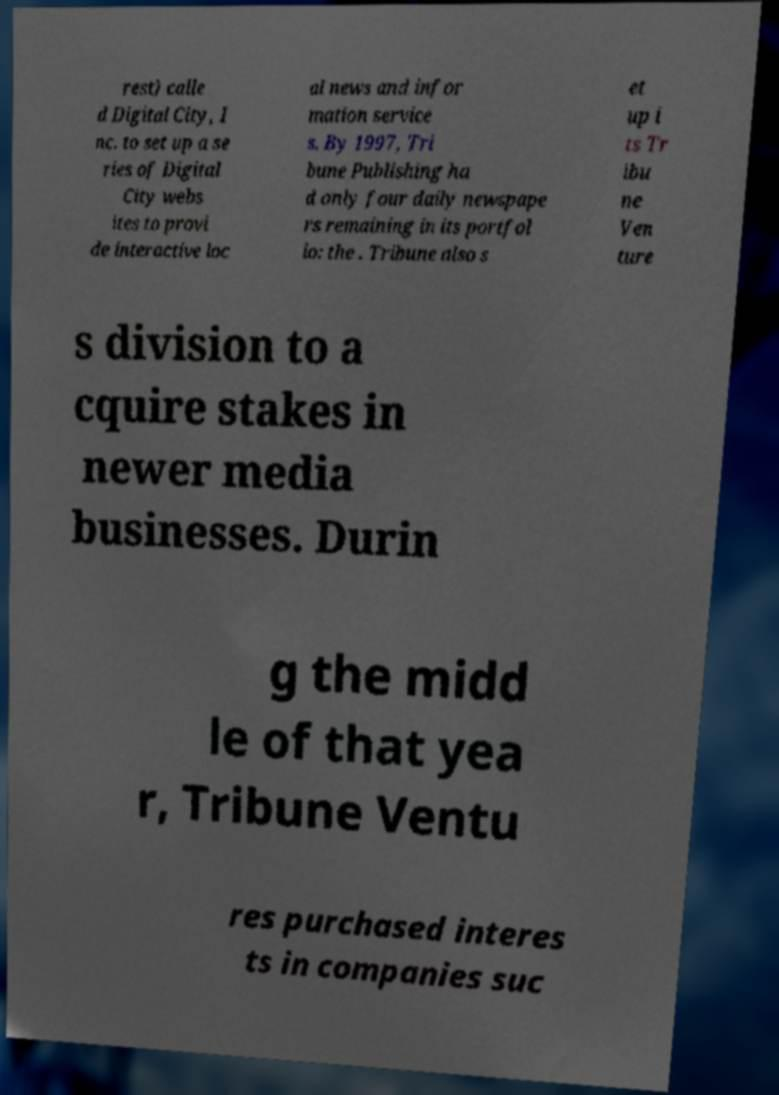What messages or text are displayed in this image? I need them in a readable, typed format. rest) calle d Digital City, I nc. to set up a se ries of Digital City webs ites to provi de interactive loc al news and infor mation service s. By 1997, Tri bune Publishing ha d only four daily newspape rs remaining in its portfol io: the . Tribune also s et up i ts Tr ibu ne Ven ture s division to a cquire stakes in newer media businesses. Durin g the midd le of that yea r, Tribune Ventu res purchased interes ts in companies suc 